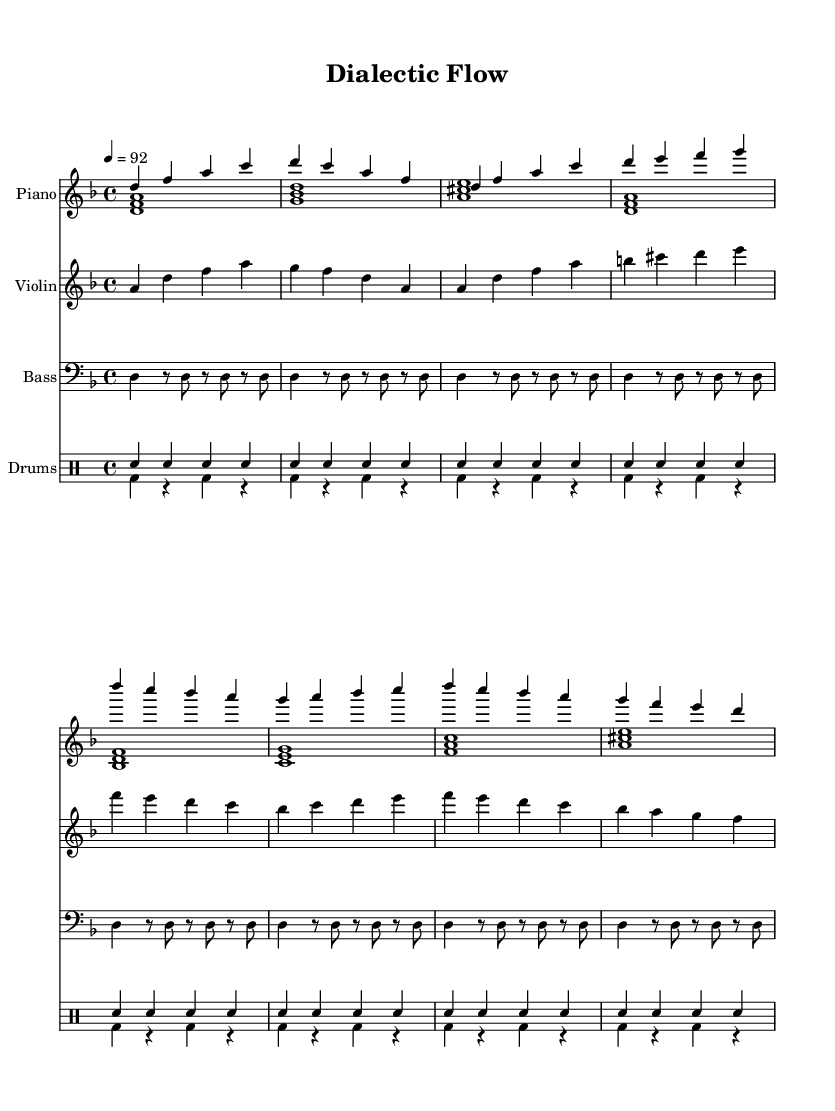What is the key signature of this music? The key signature is D minor, indicated by one flat (B flat) at the beginning of the staff.
Answer: D minor What is the time signature of the piece? The time signature is 4/4, which is noted at the beginning of the score, indicating that there are four beats per measure.
Answer: 4/4 What is the tempo marking for this piece? The tempo is marked at 92 beats per minute, specified at the start of the score.
Answer: 92 How many measures are in the piano right hand part? The piano right-hand part contains eight measures, as indicated by the grouped notes and measures shown clearly in the notation.
Answer: 8 Are there any syncopated rhythms present in the drum part? Yes, the first drum part has no rests, creating consistent eighth notes that provide a steady rhythm, while the second part features rests, indicating syncopation.
Answer: Yes What instruments are included in this score? The score includes piano, violin, bass, and drums; each instrument is notated on its own staff to provide clarity.
Answer: Piano, Violin, Bass, Drums What is the primary melodic motif in the violin part? The primary melodic motif is the ascending sequences that begin on A and often resolve around D, emphasizing the tonal center of the piece.
Answer: Ascending sequences from A to D 